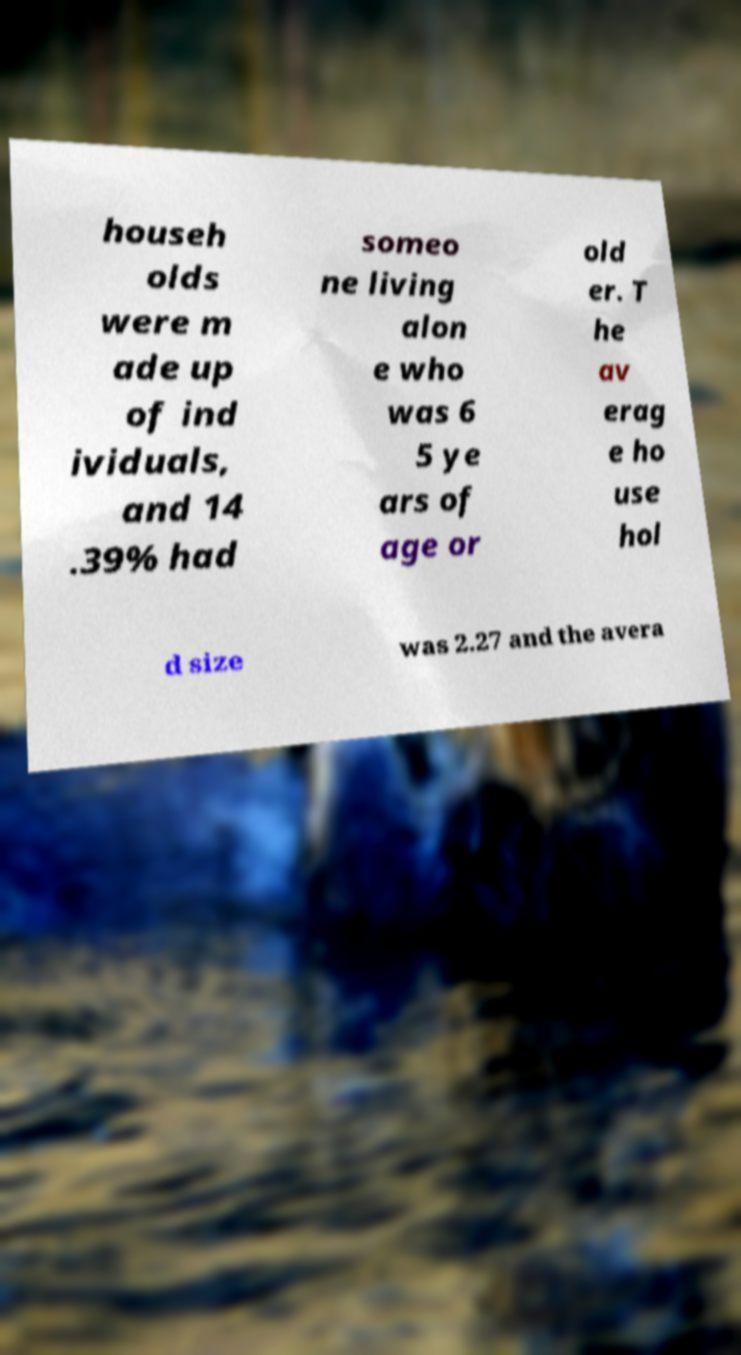There's text embedded in this image that I need extracted. Can you transcribe it verbatim? househ olds were m ade up of ind ividuals, and 14 .39% had someo ne living alon e who was 6 5 ye ars of age or old er. T he av erag e ho use hol d size was 2.27 and the avera 